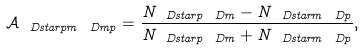Convert formula to latex. <formula><loc_0><loc_0><loc_500><loc_500>\mathcal { A } _ { \ D s t a r p m \ D m p } = \frac { N _ { \ D s t a r p \ D m } - N _ { \ D s t a r m \ D p } } { N _ { \ D s t a r p \ D m } + N _ { \ D s t a r m \ D p } } ,</formula> 